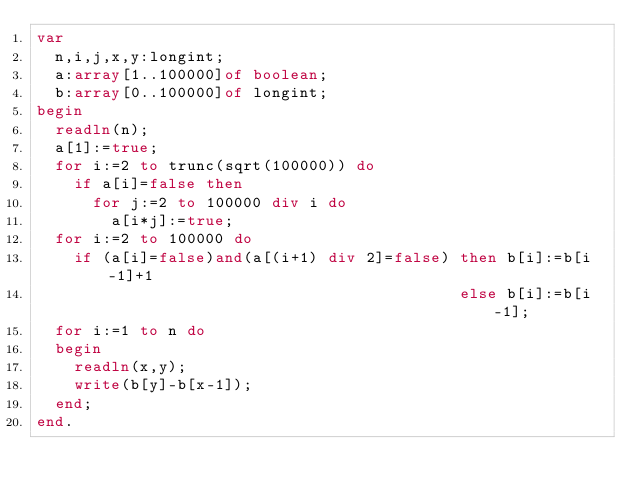<code> <loc_0><loc_0><loc_500><loc_500><_Pascal_>var
  n,i,j,x,y:longint;
  a:array[1..100000]of boolean;
  b:array[0..100000]of longint;
begin
  readln(n);
  a[1]:=true;
  for i:=2 to trunc(sqrt(100000)) do
    if a[i]=false then
      for j:=2 to 100000 div i do
        a[i*j]:=true;
  for i:=2 to 100000 do
    if (a[i]=false)and(a[(i+1) div 2]=false) then b[i]:=b[i-1]+1
                                             else b[i]:=b[i-1];
  for i:=1 to n do
  begin
    readln(x,y);
    write(b[y]-b[x-1]);
  end;
end.</code> 